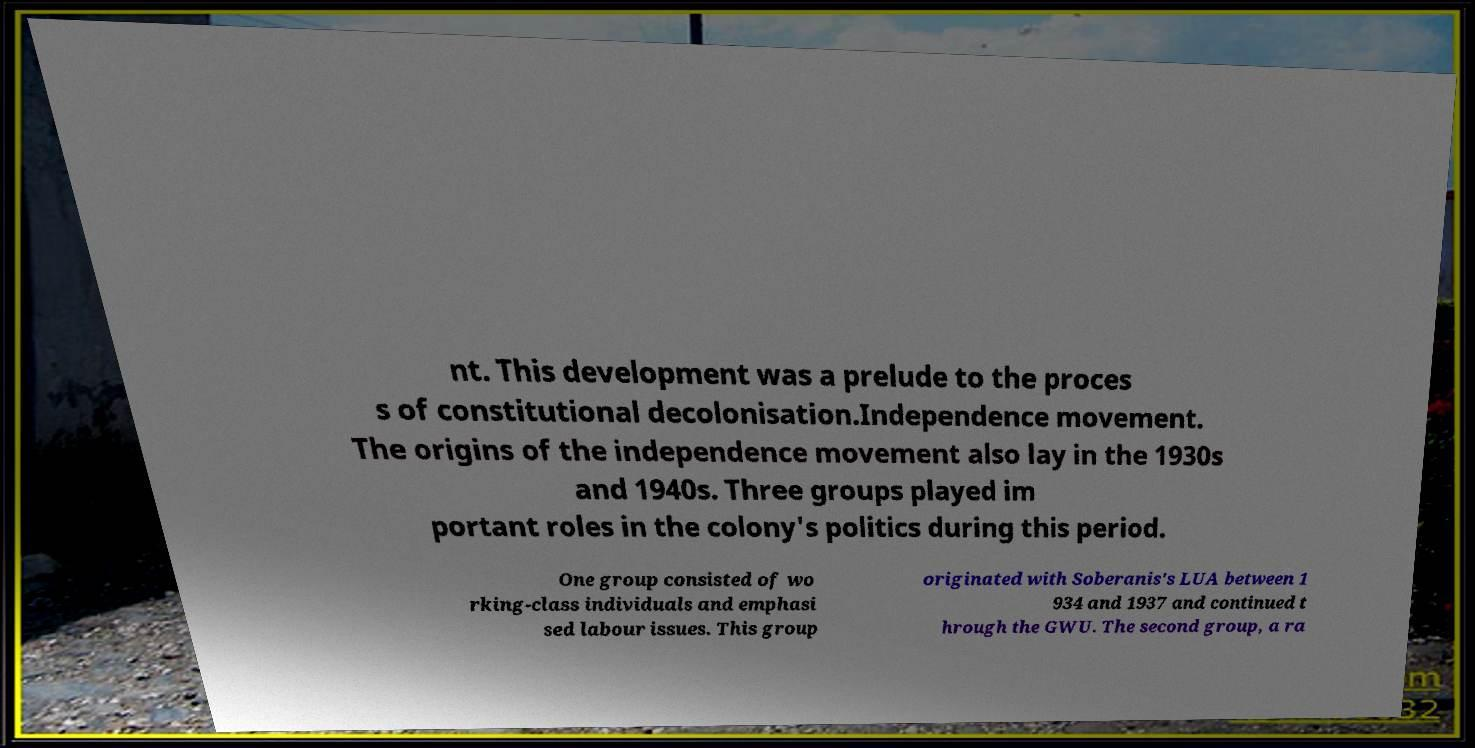Could you assist in decoding the text presented in this image and type it out clearly? nt. This development was a prelude to the proces s of constitutional decolonisation.Independence movement. The origins of the independence movement also lay in the 1930s and 1940s. Three groups played im portant roles in the colony's politics during this period. One group consisted of wo rking-class individuals and emphasi sed labour issues. This group originated with Soberanis's LUA between 1 934 and 1937 and continued t hrough the GWU. The second group, a ra 